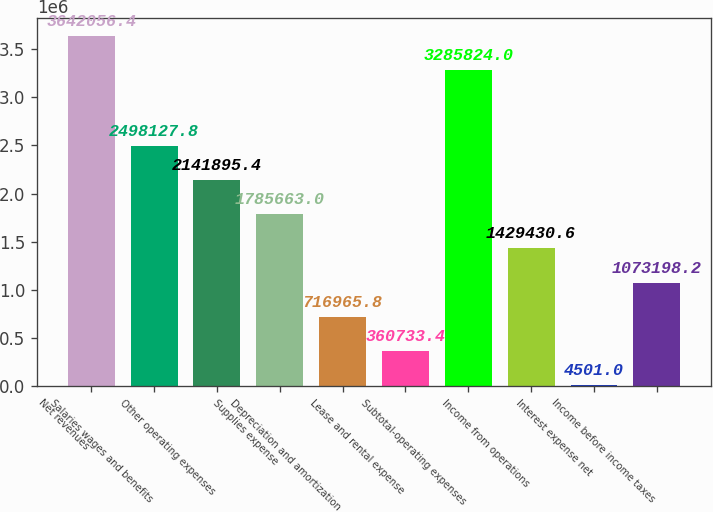Convert chart to OTSL. <chart><loc_0><loc_0><loc_500><loc_500><bar_chart><fcel>Net revenues<fcel>Salaries wages and benefits<fcel>Other operating expenses<fcel>Supplies expense<fcel>Depreciation and amortization<fcel>Lease and rental expense<fcel>Subtotal-operating expenses<fcel>Income from operations<fcel>Interest expense net<fcel>Income before income taxes<nl><fcel>3.64206e+06<fcel>2.49813e+06<fcel>2.1419e+06<fcel>1.78566e+06<fcel>716966<fcel>360733<fcel>3.28582e+06<fcel>1.42943e+06<fcel>4501<fcel>1.0732e+06<nl></chart> 